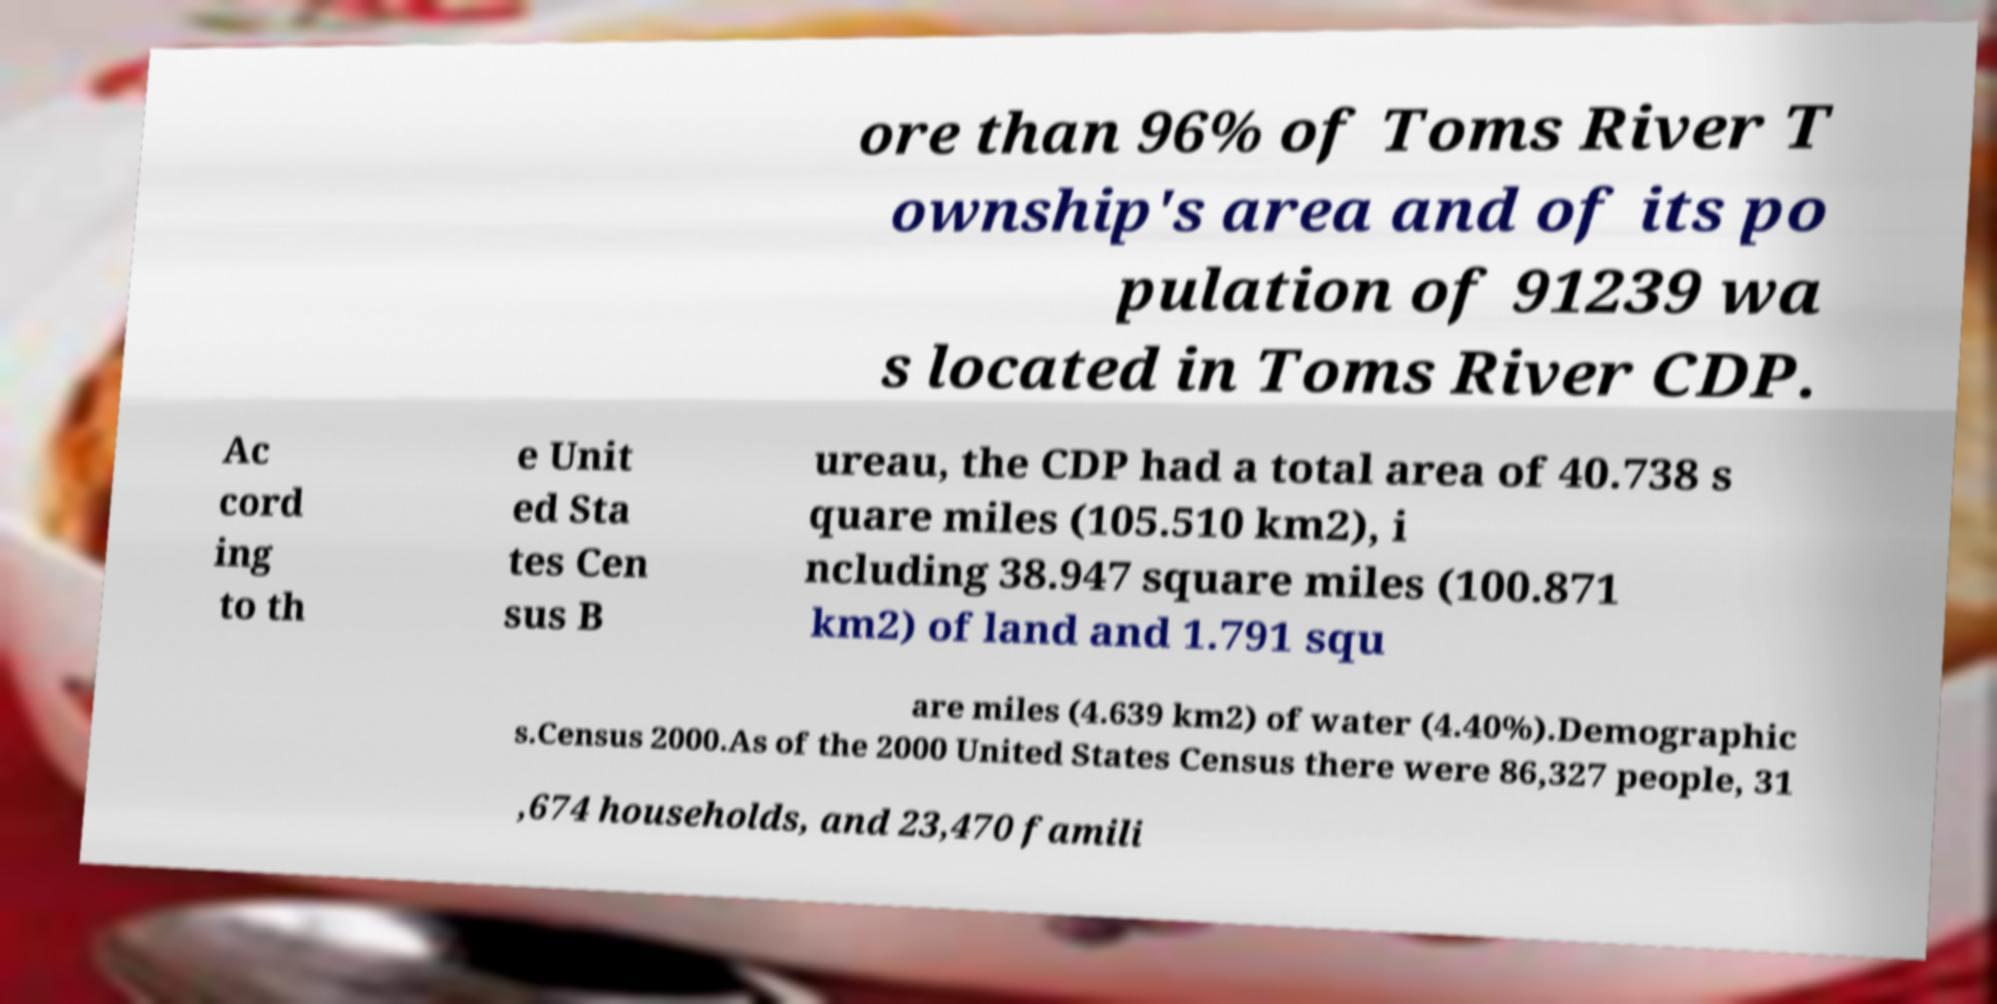Can you accurately transcribe the text from the provided image for me? ore than 96% of Toms River T ownship's area and of its po pulation of 91239 wa s located in Toms River CDP. Ac cord ing to th e Unit ed Sta tes Cen sus B ureau, the CDP had a total area of 40.738 s quare miles (105.510 km2), i ncluding 38.947 square miles (100.871 km2) of land and 1.791 squ are miles (4.639 km2) of water (4.40%).Demographic s.Census 2000.As of the 2000 United States Census there were 86,327 people, 31 ,674 households, and 23,470 famili 